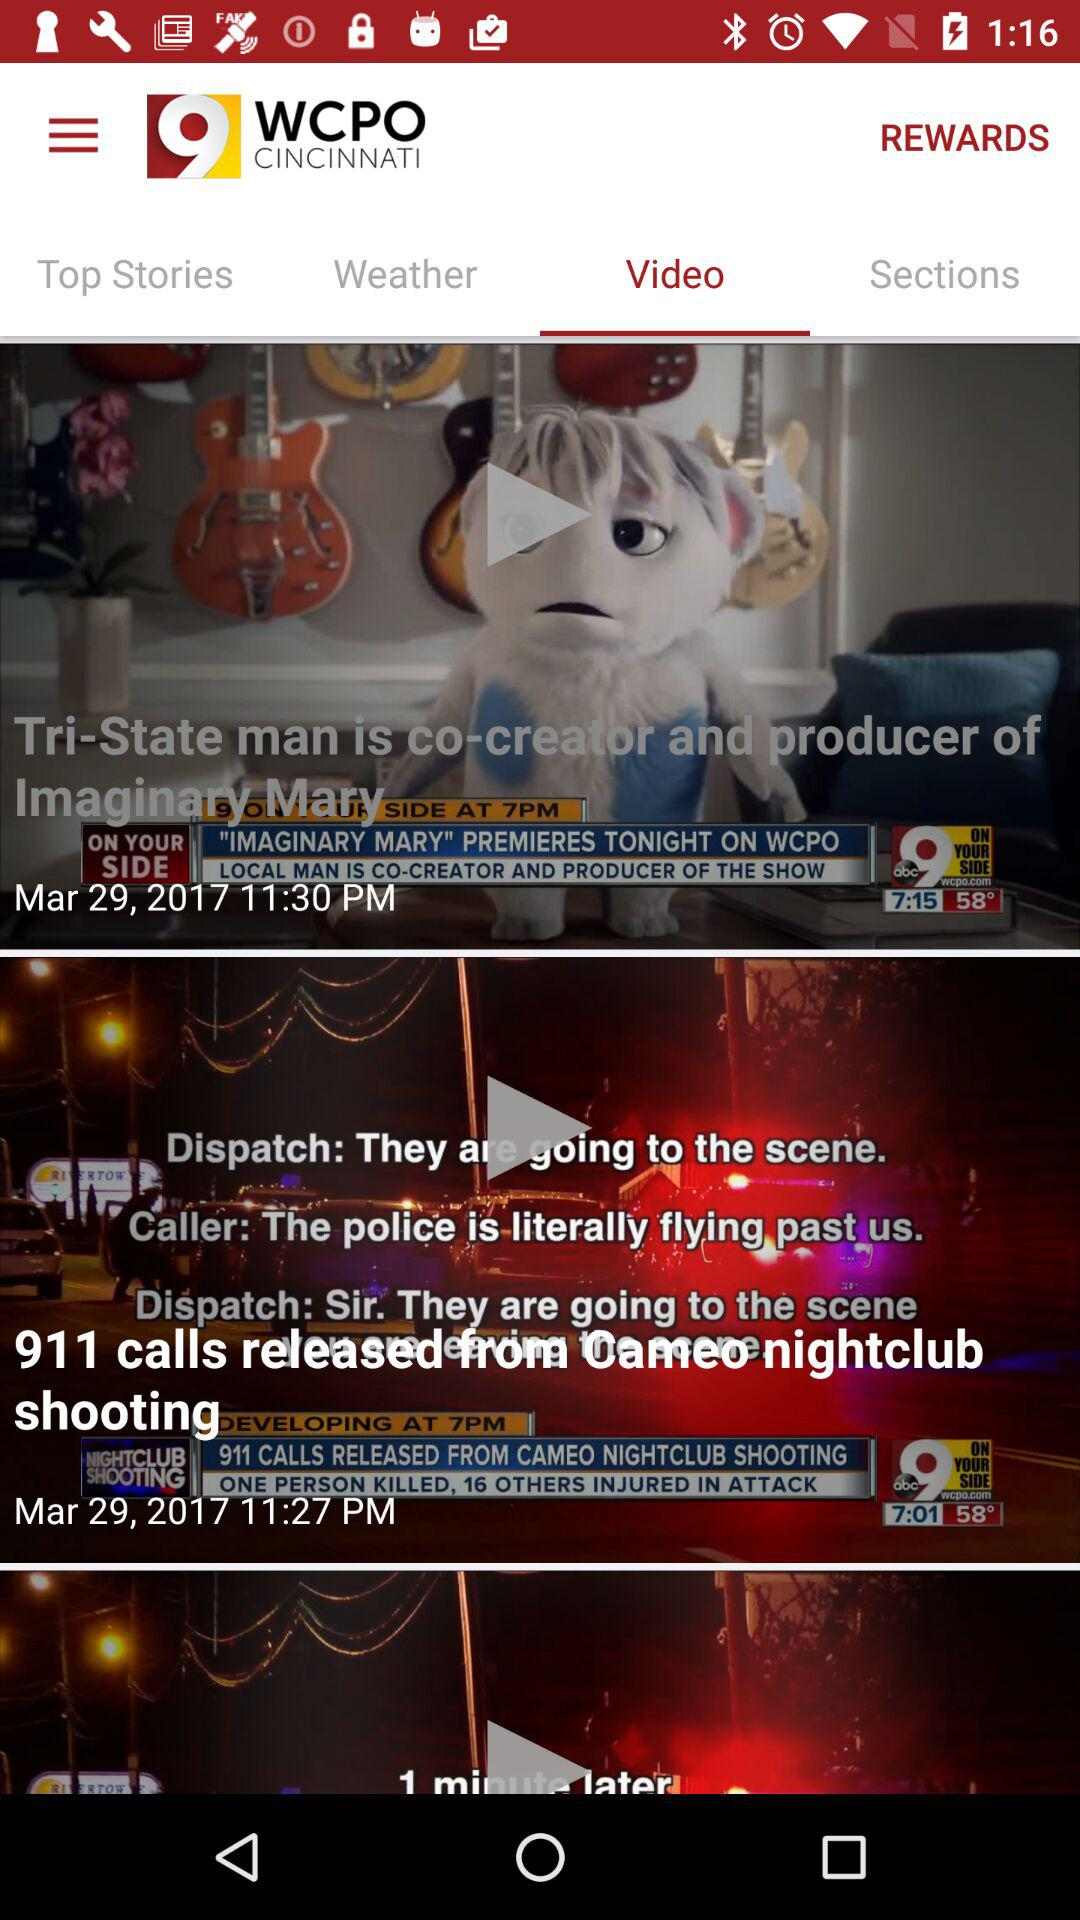When will 911 calls released from cameo nightclub shooting be released?
When the provided information is insufficient, respond with <no answer>. <no answer> 